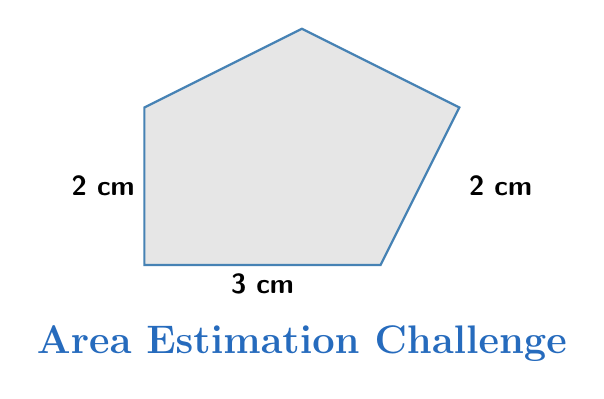Provide a solution to this math problem. To estimate the area of this irregularly shaped manga panel, we can break it down into simpler geometric shapes:

1. Divide the shape into a rectangle and a triangle:
   - Rectangle: 3 cm × 2 cm
   - Triangle: base ≈ 1 cm, height ≈ 1 cm

2. Calculate the area of the rectangle:
   $$A_{rectangle} = 3 \text{ cm} \times 2 \text{ cm} = 6 \text{ cm}^2$$

3. Calculate the area of the triangle:
   $$A_{triangle} = \frac{1}{2} \times 1 \text{ cm} \times 1 \text{ cm} = 0.5 \text{ cm}^2$$

4. Sum the areas:
   $$A_{total} = A_{rectangle} + A_{triangle} = 6 \text{ cm}^2 + 0.5 \text{ cm}^2 = 6.5 \text{ cm}^2$$

This method provides a reasonable estimate of the panel's area, given the irregular shape.
Answer: $$6.5 \text{ cm}^2$$ 